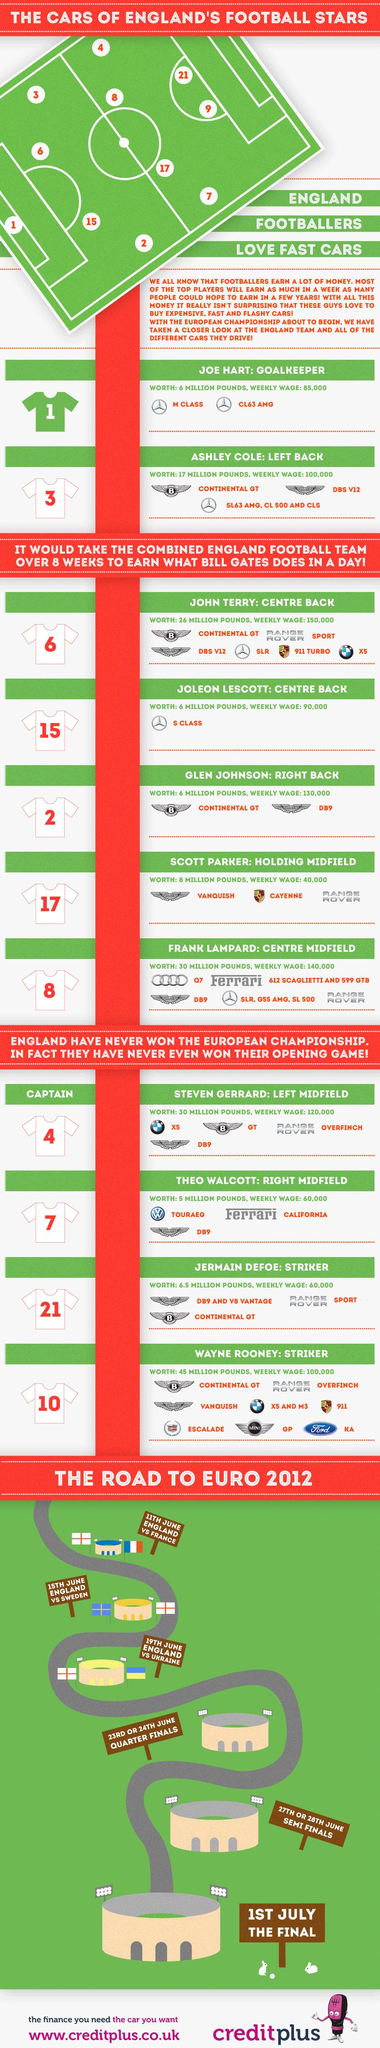Draw attention to some important aspects in this diagram. John Terry owns 6 cars. Frank Lampard uses three series of Mercedes-Benz cars. Wayne Rooney owns 8 cars. As of 2021, the Jersey number of Joe Hart, a professional football goalkeeper, is 1. The model number of the Bentley vehicle utilized by John Terry is the Continental GT. 